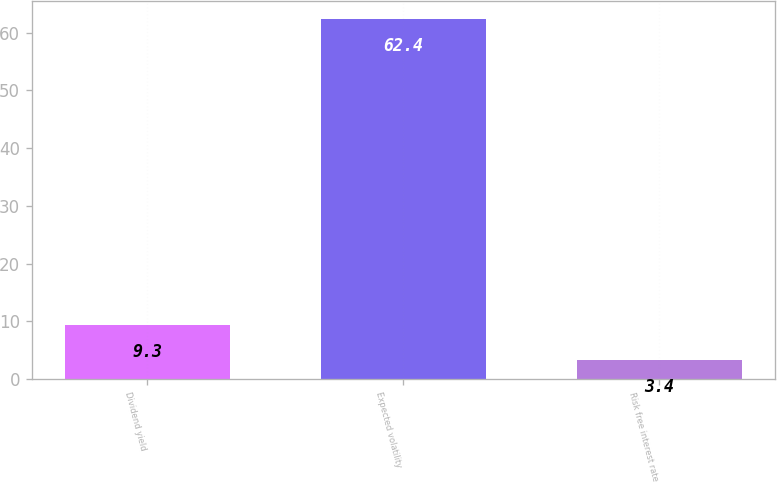Convert chart. <chart><loc_0><loc_0><loc_500><loc_500><bar_chart><fcel>Dividend yield<fcel>Expected volatility<fcel>Risk free interest rate<nl><fcel>9.3<fcel>62.4<fcel>3.4<nl></chart> 